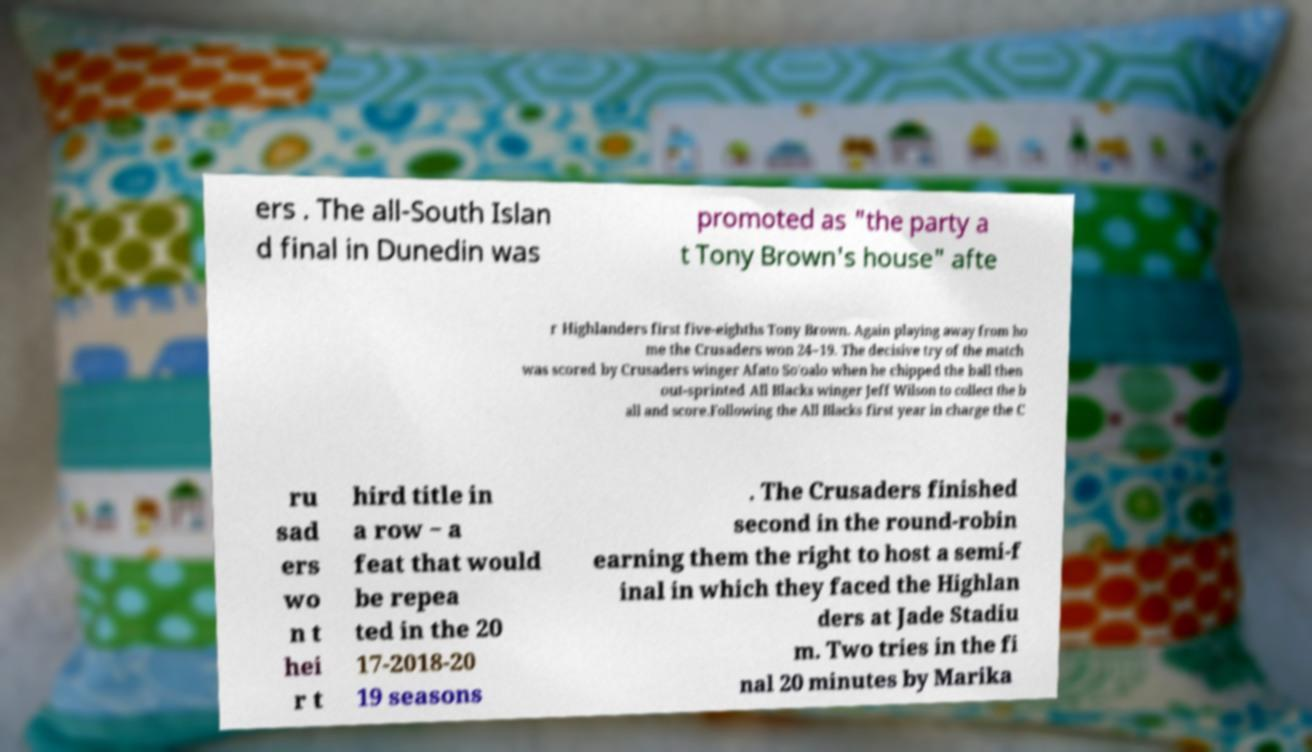Can you read and provide the text displayed in the image?This photo seems to have some interesting text. Can you extract and type it out for me? ers . The all-South Islan d final in Dunedin was promoted as "the party a t Tony Brown's house" afte r Highlanders first five-eighths Tony Brown. Again playing away from ho me the Crusaders won 24–19. The decisive try of the match was scored by Crusaders winger Afato So'oalo when he chipped the ball then out-sprinted All Blacks winger Jeff Wilson to collect the b all and score.Following the All Blacks first year in charge the C ru sad ers wo n t hei r t hird title in a row − a feat that would be repea ted in the 20 17-2018-20 19 seasons . The Crusaders finished second in the round-robin earning them the right to host a semi-f inal in which they faced the Highlan ders at Jade Stadiu m. Two tries in the fi nal 20 minutes by Marika 